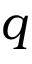<formula> <loc_0><loc_0><loc_500><loc_500>q</formula> 